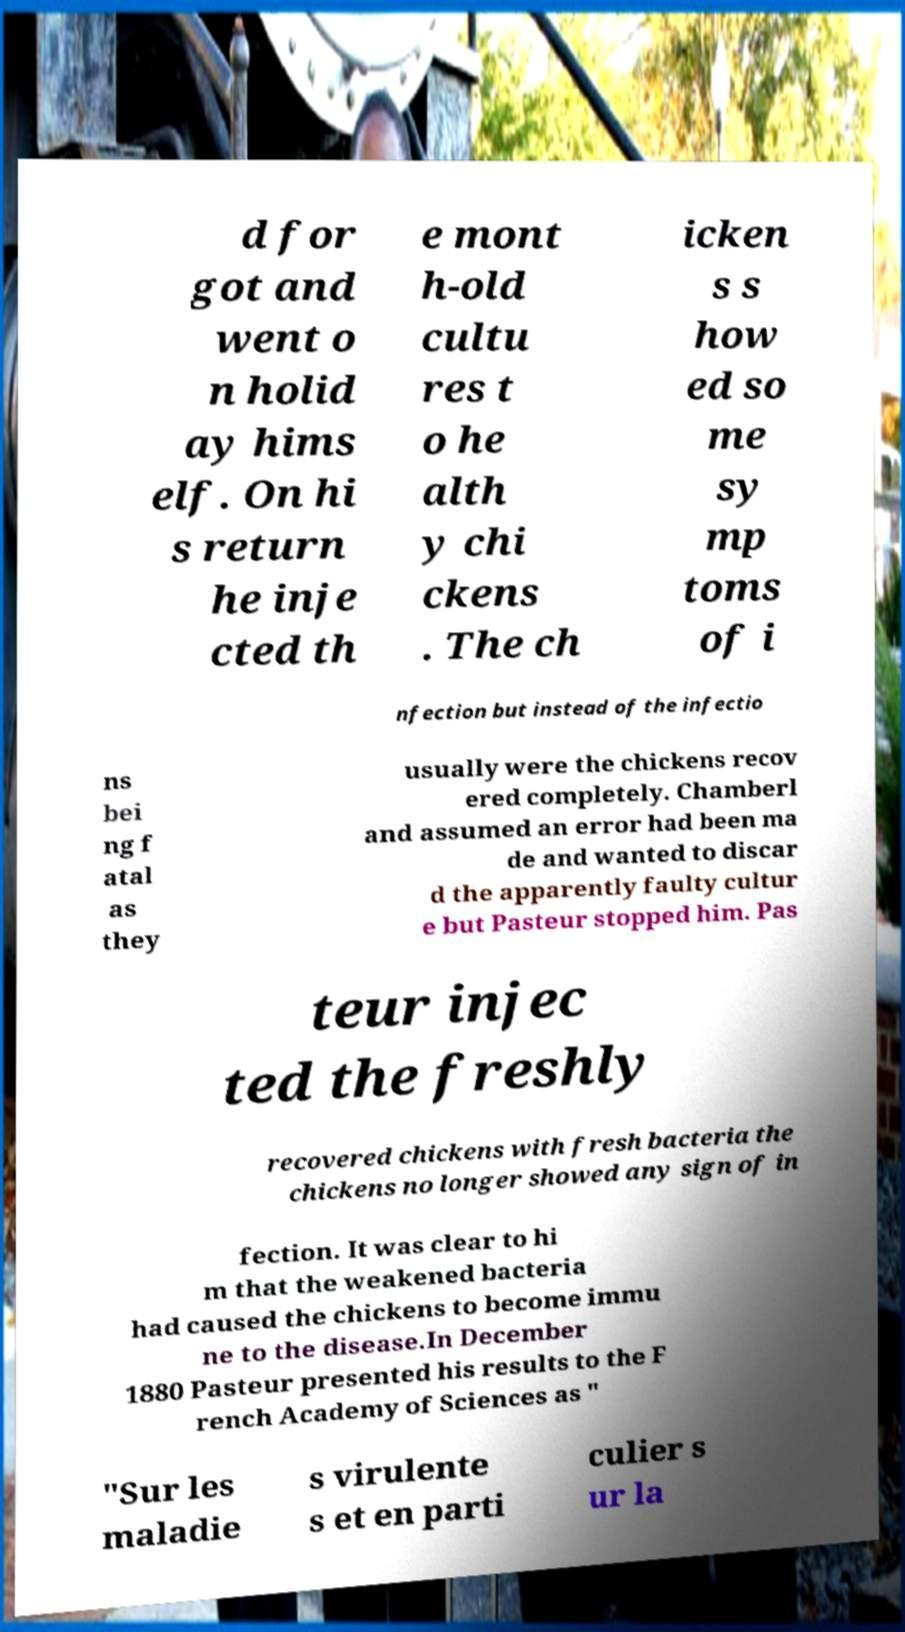I need the written content from this picture converted into text. Can you do that? d for got and went o n holid ay hims elf. On hi s return he inje cted th e mont h-old cultu res t o he alth y chi ckens . The ch icken s s how ed so me sy mp toms of i nfection but instead of the infectio ns bei ng f atal as they usually were the chickens recov ered completely. Chamberl and assumed an error had been ma de and wanted to discar d the apparently faulty cultur e but Pasteur stopped him. Pas teur injec ted the freshly recovered chickens with fresh bacteria the chickens no longer showed any sign of in fection. It was clear to hi m that the weakened bacteria had caused the chickens to become immu ne to the disease.In December 1880 Pasteur presented his results to the F rench Academy of Sciences as " "Sur les maladie s virulente s et en parti culier s ur la 